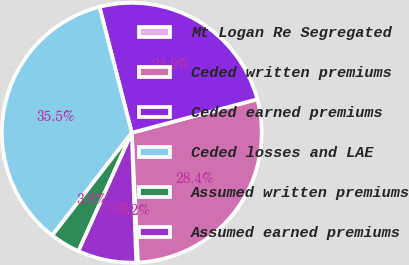Convert chart. <chart><loc_0><loc_0><loc_500><loc_500><pie_chart><fcel>Mt Logan Re Segregated<fcel>Ceded written premiums<fcel>Ceded earned premiums<fcel>Ceded losses and LAE<fcel>Assumed written premiums<fcel>Assumed earned premiums<nl><fcel>0.22%<fcel>28.38%<fcel>24.85%<fcel>35.51%<fcel>3.75%<fcel>7.28%<nl></chart> 